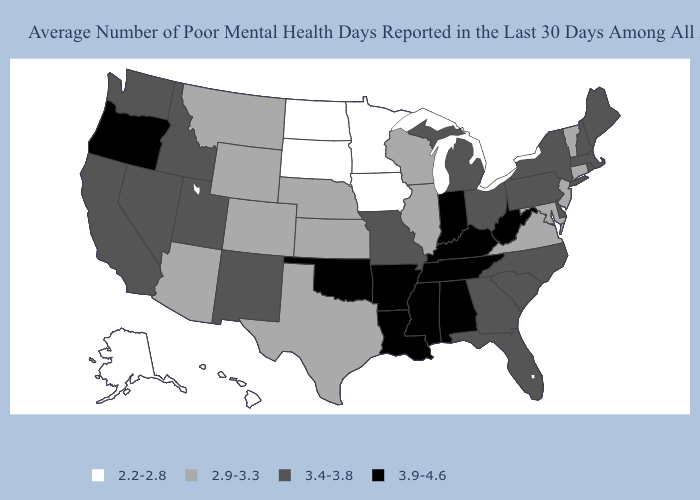Among the states that border Virginia , which have the lowest value?
Short answer required. Maryland. Name the states that have a value in the range 3.4-3.8?
Concise answer only. California, Delaware, Florida, Georgia, Idaho, Maine, Massachusetts, Michigan, Missouri, Nevada, New Hampshire, New Mexico, New York, North Carolina, Ohio, Pennsylvania, Rhode Island, South Carolina, Utah, Washington. Name the states that have a value in the range 2.9-3.3?
Give a very brief answer. Arizona, Colorado, Connecticut, Illinois, Kansas, Maryland, Montana, Nebraska, New Jersey, Texas, Vermont, Virginia, Wisconsin, Wyoming. Does Virginia have the same value as Iowa?
Concise answer only. No. Name the states that have a value in the range 2.2-2.8?
Keep it brief. Alaska, Hawaii, Iowa, Minnesota, North Dakota, South Dakota. What is the value of Virginia?
Give a very brief answer. 2.9-3.3. What is the lowest value in states that border Mississippi?
Keep it brief. 3.9-4.6. Does West Virginia have the highest value in the USA?
Answer briefly. Yes. What is the value of New York?
Concise answer only. 3.4-3.8. What is the value of Texas?
Give a very brief answer. 2.9-3.3. Name the states that have a value in the range 2.2-2.8?
Short answer required. Alaska, Hawaii, Iowa, Minnesota, North Dakota, South Dakota. Which states have the lowest value in the Northeast?
Quick response, please. Connecticut, New Jersey, Vermont. Does the map have missing data?
Short answer required. No. Which states have the lowest value in the USA?
Answer briefly. Alaska, Hawaii, Iowa, Minnesota, North Dakota, South Dakota. Does Missouri have the highest value in the USA?
Answer briefly. No. 